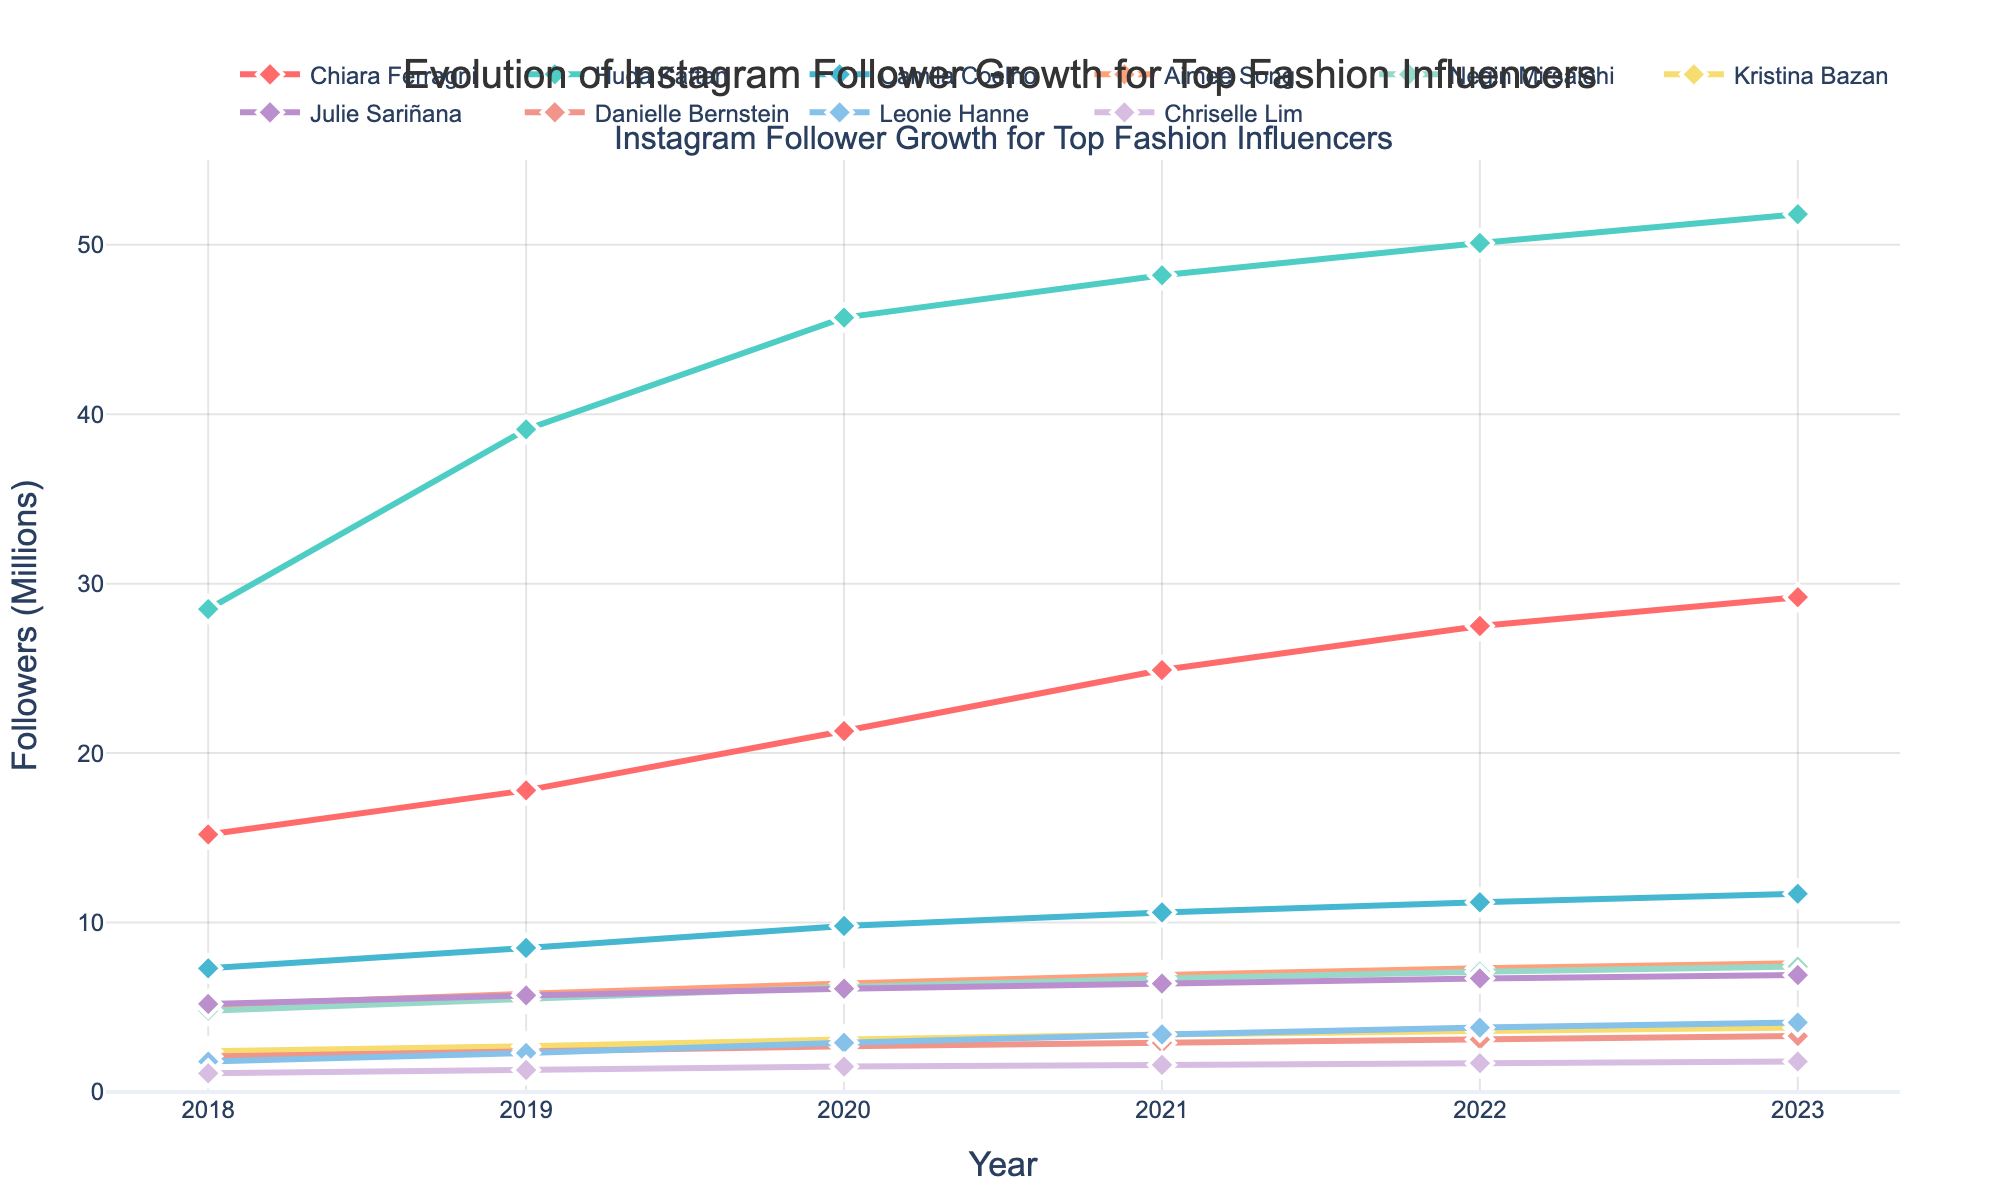Which influencer had the highest follower growth from 2018 to 2023? By examining the lines in the plot, we see that Huda Kattan had the most significant increase in followers, starting at 28.5 million in 2018 and growing to 51.8 million in 2023.
Answer: Huda Kattan Which influencer had the smallest increase in Instagram followers over the time period? Looking at the lines, Chriselle Lim had the smallest growth, starting at 1.1 million in 2018 and reaching only 1.8 million in 2023.
Answer: Chriselle Lim What is the difference in follower count between Chiara Ferragni and Julie Sariñana in 2023? In 2023, Chiara Ferragni had 29.2 million followers, and Julie Sariñana had 6.9 million. The difference is 29.2 - 6.9 = 22.3 million.
Answer: 22.3 million Which two influencers had nearly equal follower counts in 2019? Observing the lines and markers, Julie Sariñana and Aimee Song had very close follower counts, with 5.7 million and 5.8 million, respectively, in 2019.
Answer: Julie Sariñana and Aimee Song Who had a sharper increase in followers from 2019 to 2020: Huda Kattan or Negin Mirsalehi? From 2019 to 2020, Huda Kattan increased from 39.1 million to 45.7 million (6.6 million increase) while Negin Mirsalehi went from 5.5 million to 6.2 million (0.7 million increase). Thus, Huda Kattan had a sharper increase.
Answer: Huda Kattan What is the average follower count of Negin Mirsalehi over the 5-year period? Sum the follower counts of Negin Mirsalehi from 2018 to 2023, which are 4.8, 5.5, 6.2, 6.7, 7.1, and 7.4. Total is 4.8 + 5.5 + 6.2 + 6.7 + 7.1 + 7.4 = 37.7. 
The average is 37.7 / 6 = 6.28 million.
Answer: 6.28 million In which year did Chiara Ferragni surpass 20 million followers for the first time? By examining the line for Chiara Ferragni, we see that she had 21.3 million followers in 2020. This is the first year she surpassed 20 million followers.
Answer: 2020 By how much did Camila Coelho's followers grow from 2021 to 2023? Camila Coelho's followers were 10.6 million in 2021 and 11.7 million in 2023. The growth is 11.7 - 10.6 = 1.1 million.
Answer: 1.1 million Which influencer had consistently lower followers than Danielle Bernstein throughout the period? By analyzing the lines, Chriselle Lim consistently had lower followers than Danielle Bernstein during the whole period from 2018 to 2023.
Answer: Chriselle Lim Which year shows the steepest increase in followers for Leonie Hanne? The steepest increase in followers for Leonie Hanne is observed between 2019 and 2020, where her followers grew from 2.3 million to 2.9 million.
Answer: 2019-2020 